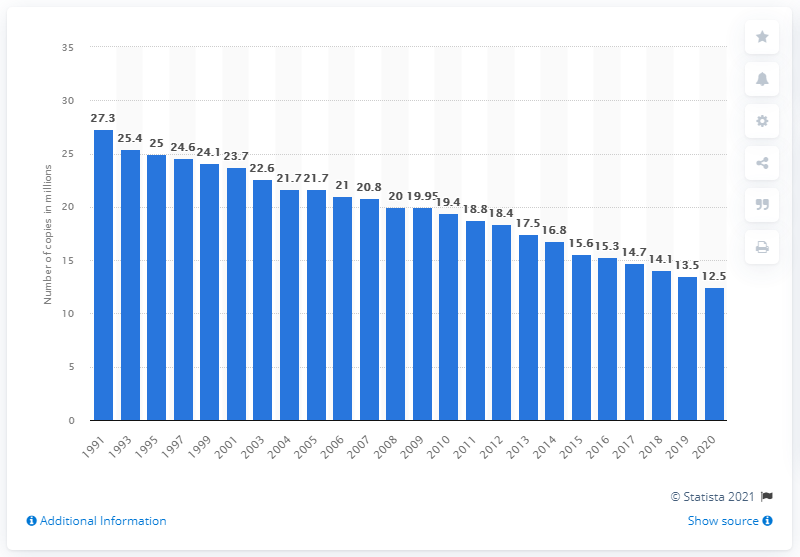Indicate a few pertinent items in this graphic. In 1991, the number of copies of German daily newspapers in circulation was approximately 27,300. The daily newspaper circulation in Germany in 2020 was 12,500. 